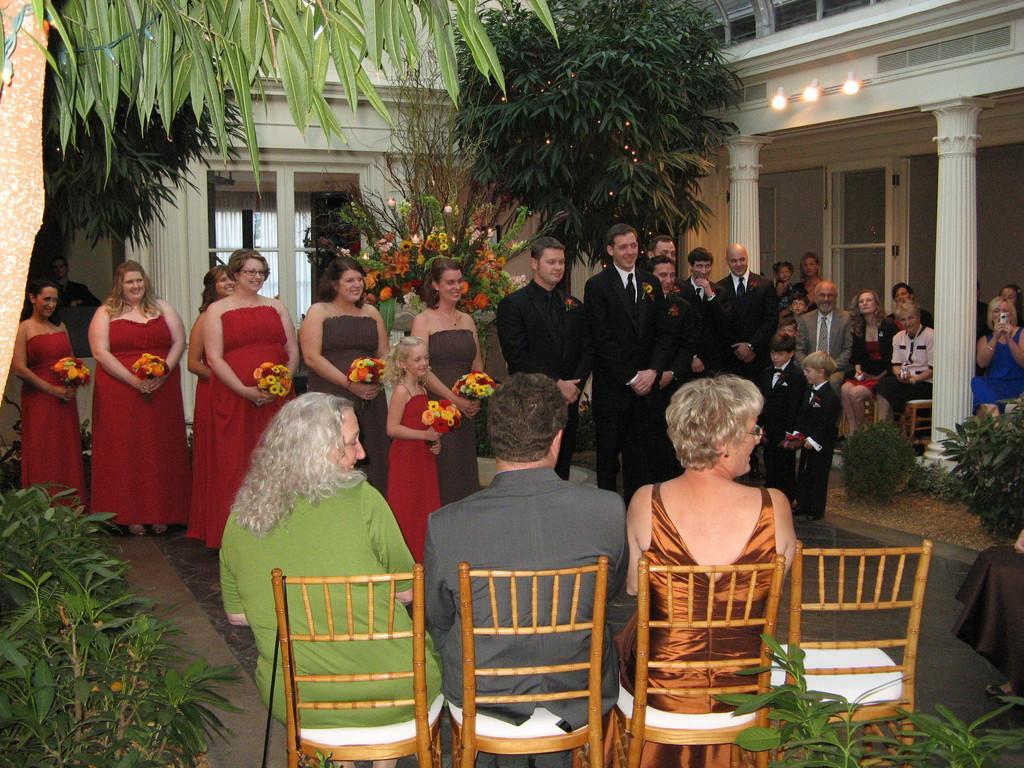Describe this image in one or two sentences. This image is clicked in a function where there are so many people. Three of them are sitting on chairs in the bottom side. Lights on the top right side ,there are trees in this image. There are bushes in the bottom left corner. There are pillars on right side. 